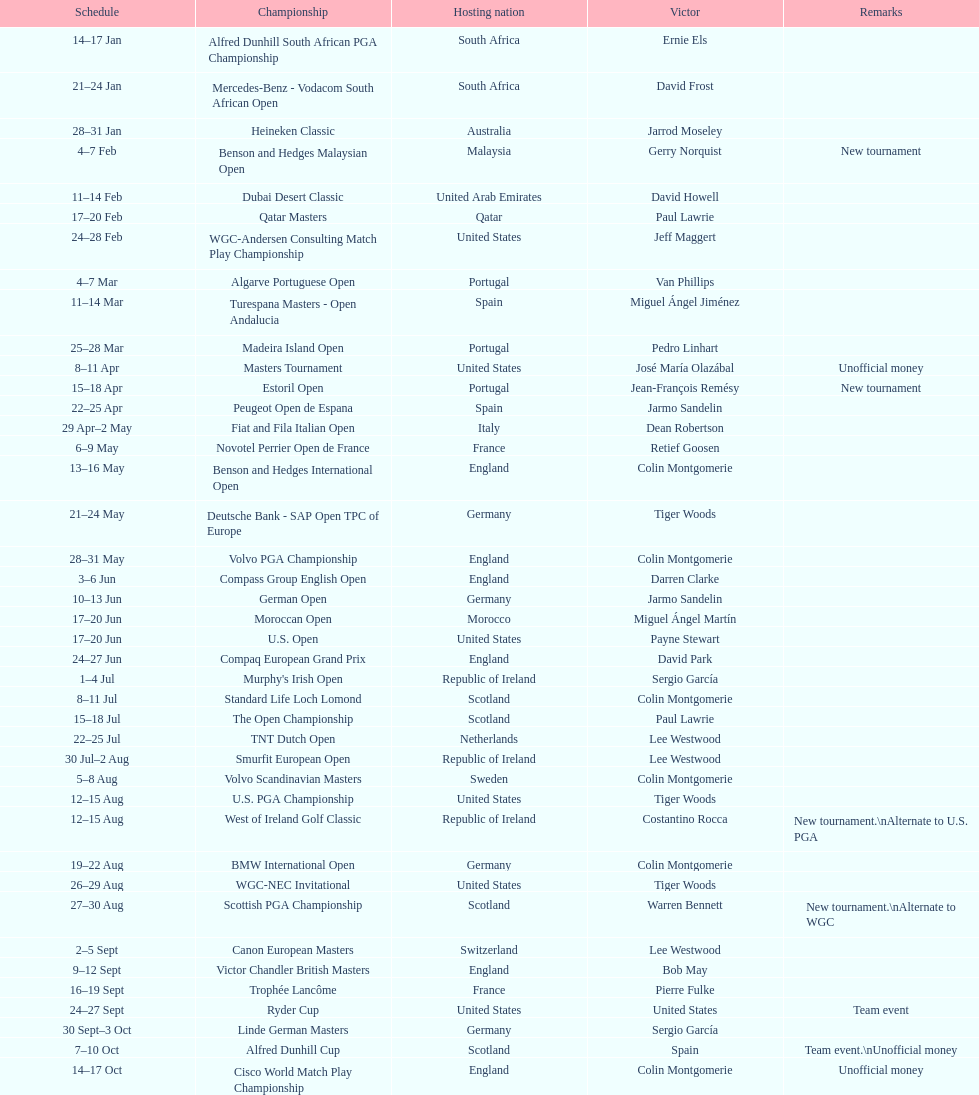Help me parse the entirety of this table. {'header': ['Schedule', 'Championship', 'Hosting nation', 'Victor', 'Remarks'], 'rows': [['14–17\xa0Jan', 'Alfred Dunhill South African PGA Championship', 'South Africa', 'Ernie Els', ''], ['21–24\xa0Jan', 'Mercedes-Benz - Vodacom South African Open', 'South Africa', 'David Frost', ''], ['28–31\xa0Jan', 'Heineken Classic', 'Australia', 'Jarrod Moseley', ''], ['4–7\xa0Feb', 'Benson and Hedges Malaysian Open', 'Malaysia', 'Gerry Norquist', 'New tournament'], ['11–14\xa0Feb', 'Dubai Desert Classic', 'United Arab Emirates', 'David Howell', ''], ['17–20\xa0Feb', 'Qatar Masters', 'Qatar', 'Paul Lawrie', ''], ['24–28\xa0Feb', 'WGC-Andersen Consulting Match Play Championship', 'United States', 'Jeff Maggert', ''], ['4–7\xa0Mar', 'Algarve Portuguese Open', 'Portugal', 'Van Phillips', ''], ['11–14\xa0Mar', 'Turespana Masters - Open Andalucia', 'Spain', 'Miguel Ángel Jiménez', ''], ['25–28\xa0Mar', 'Madeira Island Open', 'Portugal', 'Pedro Linhart', ''], ['8–11\xa0Apr', 'Masters Tournament', 'United States', 'José María Olazábal', 'Unofficial money'], ['15–18\xa0Apr', 'Estoril Open', 'Portugal', 'Jean-François Remésy', 'New tournament'], ['22–25\xa0Apr', 'Peugeot Open de Espana', 'Spain', 'Jarmo Sandelin', ''], ['29\xa0Apr–2\xa0May', 'Fiat and Fila Italian Open', 'Italy', 'Dean Robertson', ''], ['6–9\xa0May', 'Novotel Perrier Open de France', 'France', 'Retief Goosen', ''], ['13–16\xa0May', 'Benson and Hedges International Open', 'England', 'Colin Montgomerie', ''], ['21–24\xa0May', 'Deutsche Bank - SAP Open TPC of Europe', 'Germany', 'Tiger Woods', ''], ['28–31\xa0May', 'Volvo PGA Championship', 'England', 'Colin Montgomerie', ''], ['3–6\xa0Jun', 'Compass Group English Open', 'England', 'Darren Clarke', ''], ['10–13\xa0Jun', 'German Open', 'Germany', 'Jarmo Sandelin', ''], ['17–20\xa0Jun', 'Moroccan Open', 'Morocco', 'Miguel Ángel Martín', ''], ['17–20\xa0Jun', 'U.S. Open', 'United States', 'Payne Stewart', ''], ['24–27\xa0Jun', 'Compaq European Grand Prix', 'England', 'David Park', ''], ['1–4\xa0Jul', "Murphy's Irish Open", 'Republic of Ireland', 'Sergio García', ''], ['8–11\xa0Jul', 'Standard Life Loch Lomond', 'Scotland', 'Colin Montgomerie', ''], ['15–18\xa0Jul', 'The Open Championship', 'Scotland', 'Paul Lawrie', ''], ['22–25\xa0Jul', 'TNT Dutch Open', 'Netherlands', 'Lee Westwood', ''], ['30\xa0Jul–2\xa0Aug', 'Smurfit European Open', 'Republic of Ireland', 'Lee Westwood', ''], ['5–8\xa0Aug', 'Volvo Scandinavian Masters', 'Sweden', 'Colin Montgomerie', ''], ['12–15\xa0Aug', 'U.S. PGA Championship', 'United States', 'Tiger Woods', ''], ['12–15\xa0Aug', 'West of Ireland Golf Classic', 'Republic of Ireland', 'Costantino Rocca', 'New tournament.\\nAlternate to U.S. PGA'], ['19–22\xa0Aug', 'BMW International Open', 'Germany', 'Colin Montgomerie', ''], ['26–29\xa0Aug', 'WGC-NEC Invitational', 'United States', 'Tiger Woods', ''], ['27–30\xa0Aug', 'Scottish PGA Championship', 'Scotland', 'Warren Bennett', 'New tournament.\\nAlternate to WGC'], ['2–5\xa0Sept', 'Canon European Masters', 'Switzerland', 'Lee Westwood', ''], ['9–12\xa0Sept', 'Victor Chandler British Masters', 'England', 'Bob May', ''], ['16–19\xa0Sept', 'Trophée Lancôme', 'France', 'Pierre Fulke', ''], ['24–27\xa0Sept', 'Ryder Cup', 'United States', 'United States', 'Team event'], ['30\xa0Sept–3\xa0Oct', 'Linde German Masters', 'Germany', 'Sergio García', ''], ['7–10\xa0Oct', 'Alfred Dunhill Cup', 'Scotland', 'Spain', 'Team event.\\nUnofficial money'], ['14–17\xa0Oct', 'Cisco World Match Play Championship', 'England', 'Colin Montgomerie', 'Unofficial money'], ['14–17\xa0Oct', 'Sarazen World Open', 'Spain', 'Thomas Bjørn', 'New tournament'], ['21–24\xa0Oct', 'Belgacom Open', 'Belgium', 'Robert Karlsson', ''], ['28–31\xa0Oct', 'Volvo Masters', 'Spain', 'Miguel Ángel Jiménez', ''], ['4–7\xa0Nov', 'WGC-American Express Championship', 'Spain', 'Tiger Woods', ''], ['18–21\xa0Nov', 'World Cup of Golf', 'Malaysia', 'United States', 'Team event.\\nUnofficial money']]} Other than qatar masters, name a tournament that was in february. Dubai Desert Classic. 